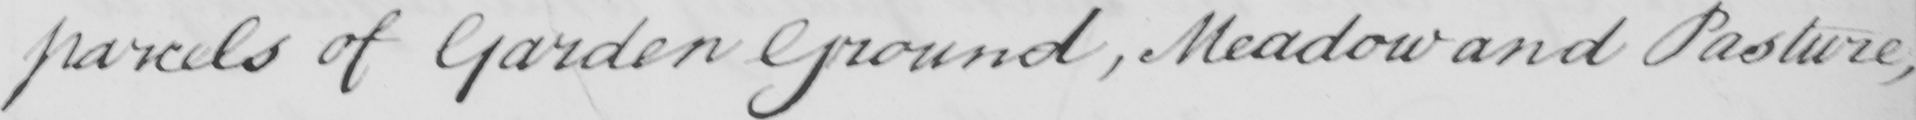Please transcribe the handwritten text in this image. parcels of Garden Ground , Meadow and Pasture , 